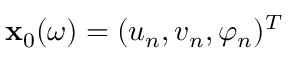Convert formula to latex. <formula><loc_0><loc_0><loc_500><loc_500>x _ { 0 } ( \omega ) = ( u _ { n } , v _ { n } , \varphi _ { n } ) ^ { T }</formula> 